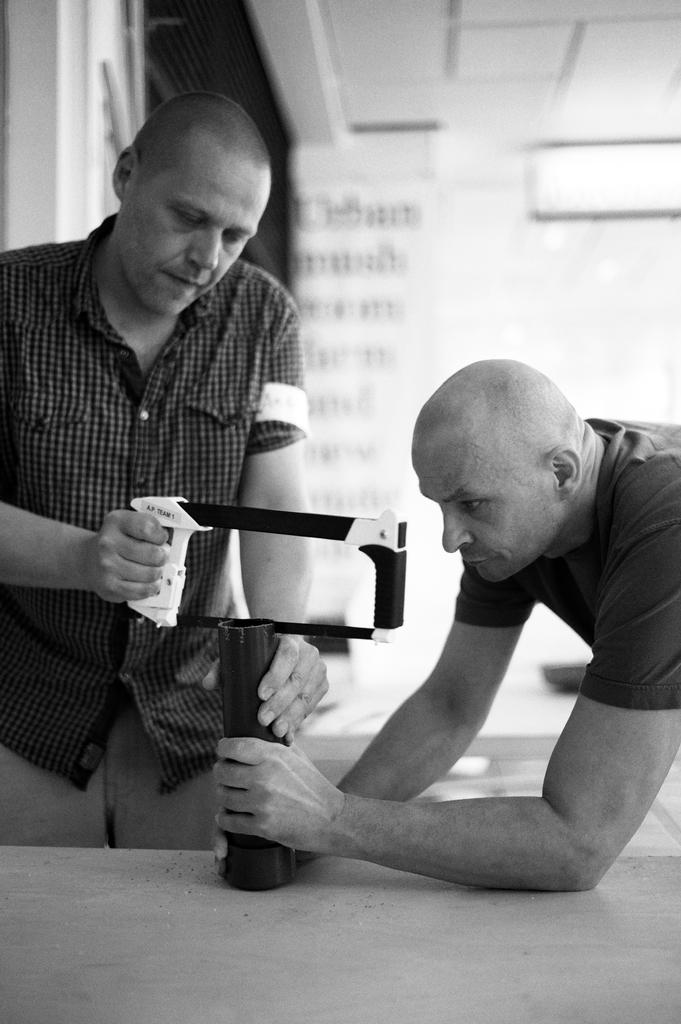How many people are in the image? There are two persons in the image. What are the persons wearing? The persons are wearing clothes. Can you describe the position of the person on the left side of the image? The person on the left side is holding a pipe and saw with his hands. What type of music can be heard in the background of the image? There is no music present in the image, as it is a still photograph. How many children are visible in the image? There are no children visible in the image, as it features two adults. 